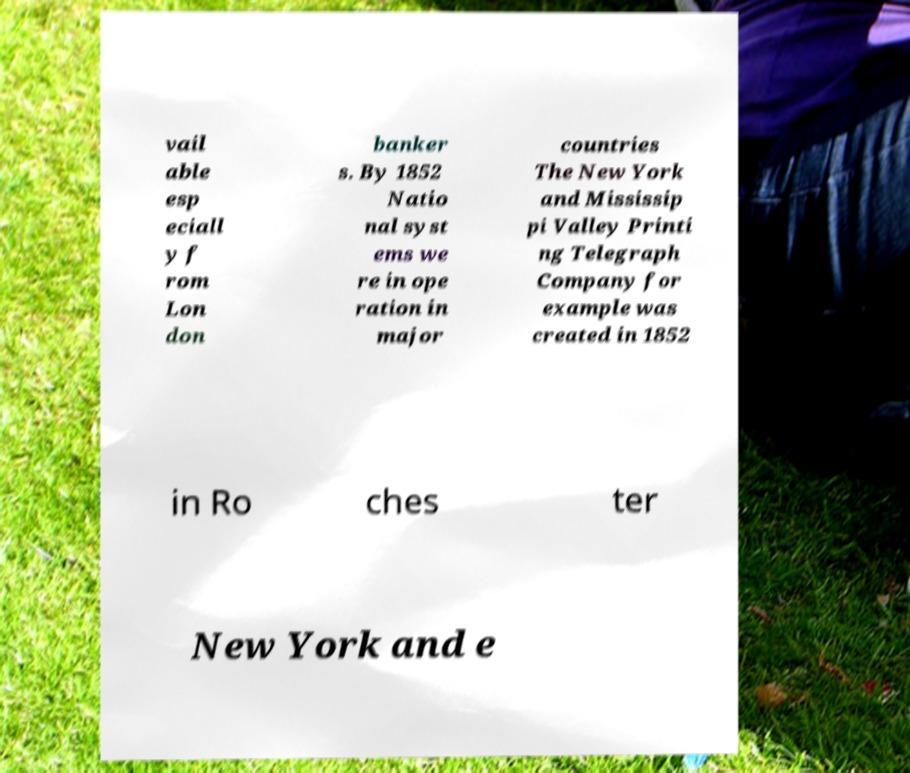I need the written content from this picture converted into text. Can you do that? vail able esp eciall y f rom Lon don banker s. By 1852 Natio nal syst ems we re in ope ration in major countries The New York and Mississip pi Valley Printi ng Telegraph Company for example was created in 1852 in Ro ches ter New York and e 